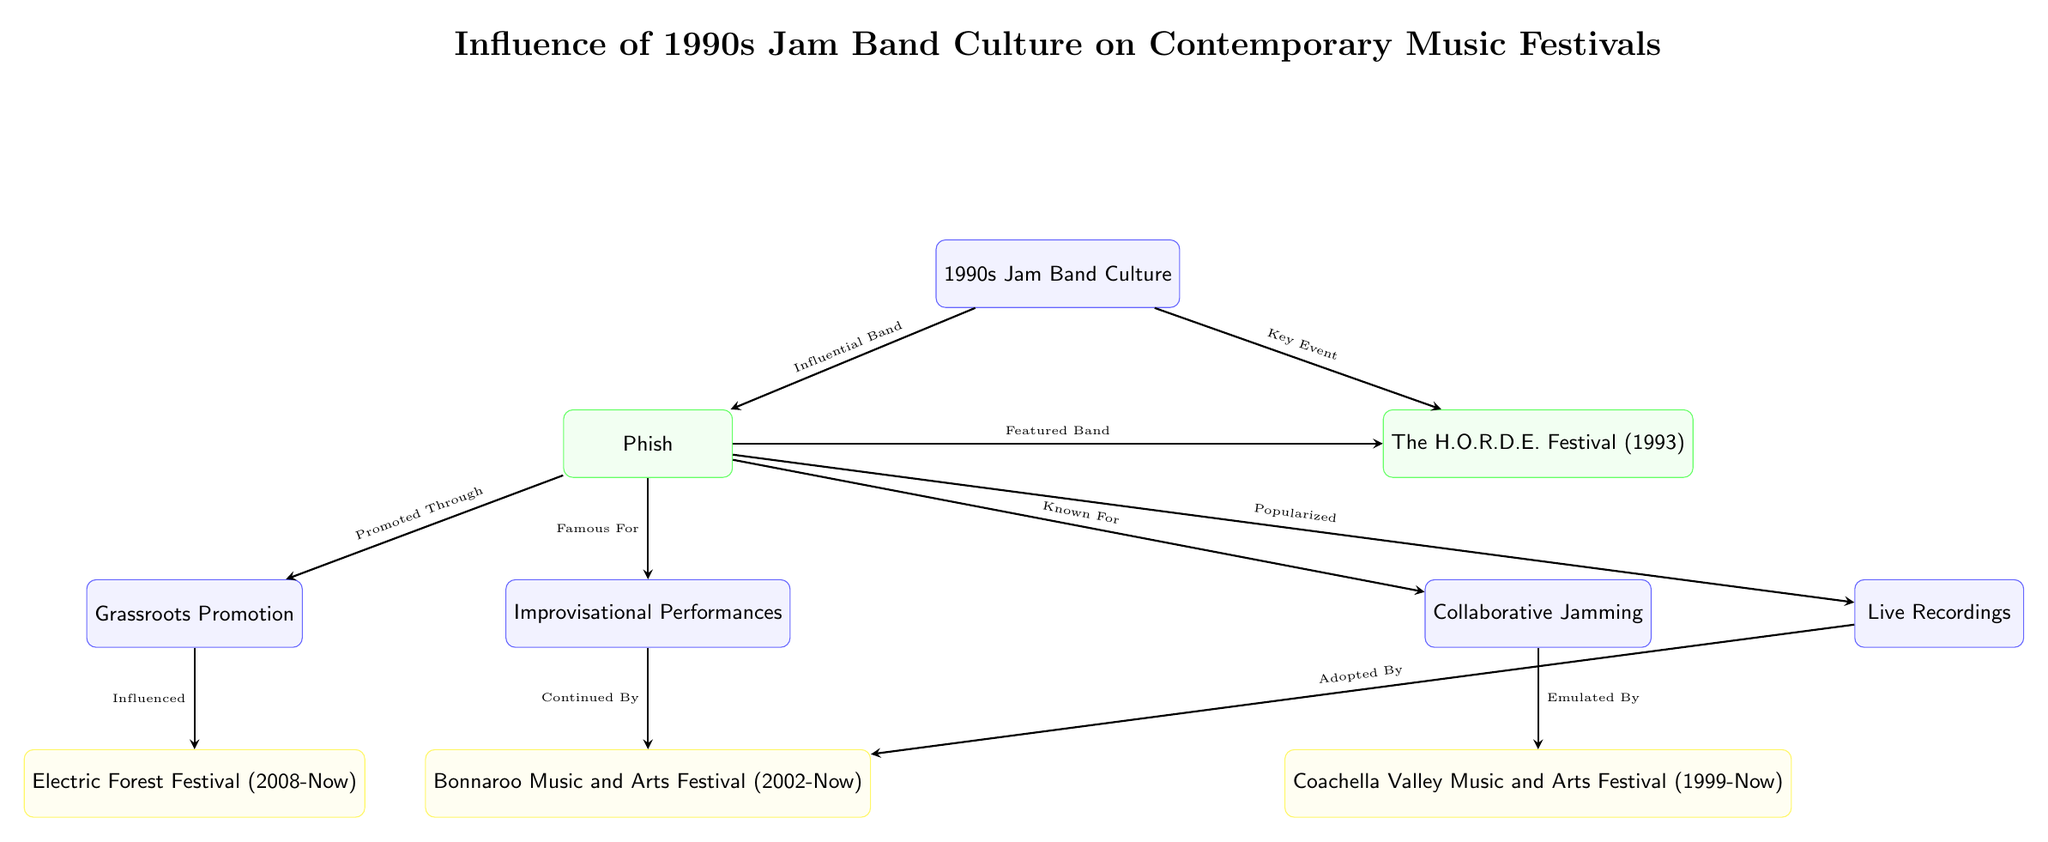What is the key event mentioned related to 1990s Jam Band Culture? The diagram indicates that "The H.O.R.D.E. Festival (1993)" is a key event related to 1990s Jam Band Culture by connecting it with an arrow marked "Key Event" from the 1990s Jam Band Culture node.
Answer: The H.O.R.D.E. Festival (1993) What does Phish get recognized for, according to the diagram? The diagram associates Phish with "Improvisational Performances," which is indicated by the arrow directing from Phish to that node labeled "Famous For."
Answer: Improvisational Performances How many contemporary music festivals are shown in the diagram? The diagram highlights three contemporary music festivals: Bonnaroo, Coachella, and Electric Forest, all represented in yellow boxes.
Answer: 3 Which music festival is associated with "Emulated By"? The diagram shows that "Coachella Valley Music and Arts Festival (1999-Now)" is linked to the "Collaborative Jamming" node with the arrow labeled "Emulated By."
Answer: Coachella Valley Music and Arts Festival (1999-Now) What influence does Grassroots Promotion have according to the diagram? The diagram connects "Grassroots Promotion" directly to "Electric Forest Festival (2008-Now," indicating that Grassroots Promotion has influenced this festival, as shown by the arrow labeled "Influenced."
Answer: Electric Forest Festival (2008-Now) How is the impact of Phish on the H.O.R.D.E. Festival characterized? The diagram reflects the relationship between Phish and the H.O.R.D.E. Festival with an arrow labeled "Featured Band," implying that Phish played a crucial role in the H.O.R.D.E. Festival.
Answer: Featured Band What type of performance is sustained by Bonnaroo according to the flow of the diagram? The diagram suggests that "Improvisational Performances," stemming from Phish, underpins the Bonnaroo Festival, as displayed by the directional arrow labeled "Continued By."
Answer: Improvisational Performances Which festival adopted the notion of live recordings? The diagram indicates that "Bonnaroo Music and Arts Festival (2002-Now)" adopted the notion of live recordings, indicated by the arrow labeled "Adopted By."
Answer: Bonnaroo Music and Arts Festival (2002-Now) 